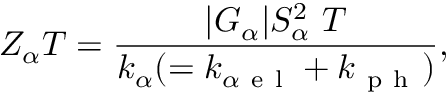<formula> <loc_0><loc_0><loc_500><loc_500>Z _ { \alpha } T = \frac { | G _ { \alpha } | S _ { \alpha } ^ { 2 } T } { k _ { \alpha } ( = k _ { \alpha e l } + k _ { p h } ) } ,</formula> 